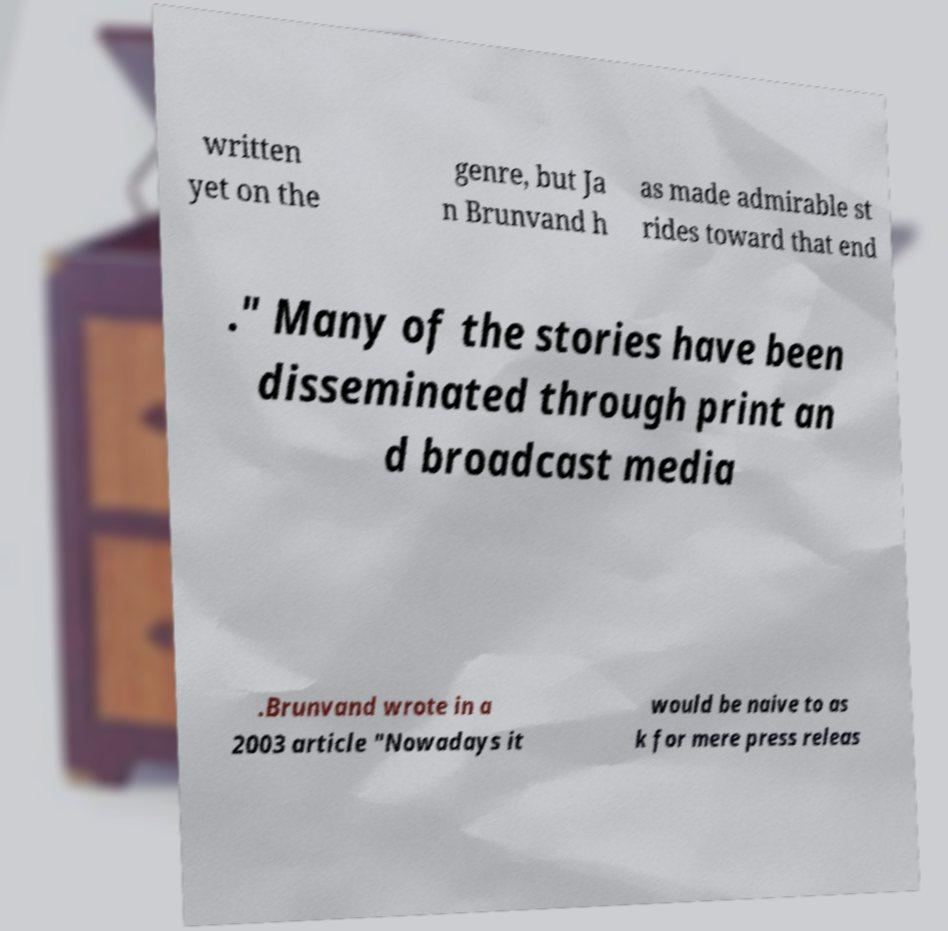Please identify and transcribe the text found in this image. written yet on the genre, but Ja n Brunvand h as made admirable st rides toward that end ." Many of the stories have been disseminated through print an d broadcast media .Brunvand wrote in a 2003 article "Nowadays it would be naive to as k for mere press releas 